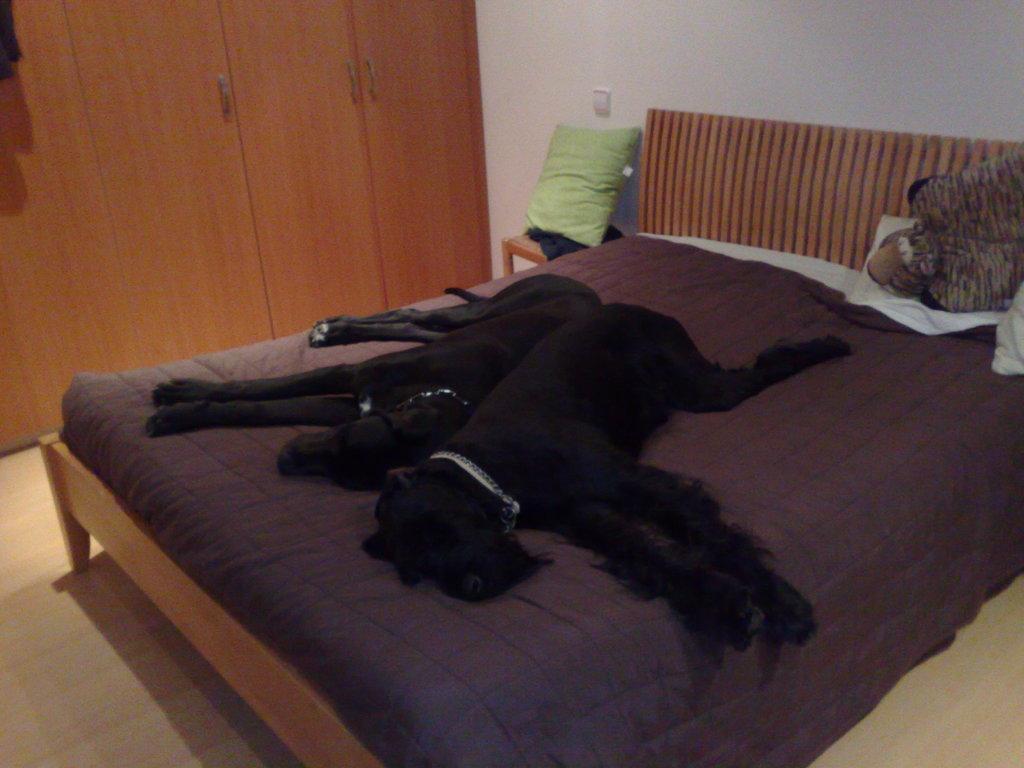How would you summarize this image in a sentence or two? In this image i can see 2 black dogs sleeping on the bed in the background i can see a pillow, a wall, a switch board and a wooden cupboard. 